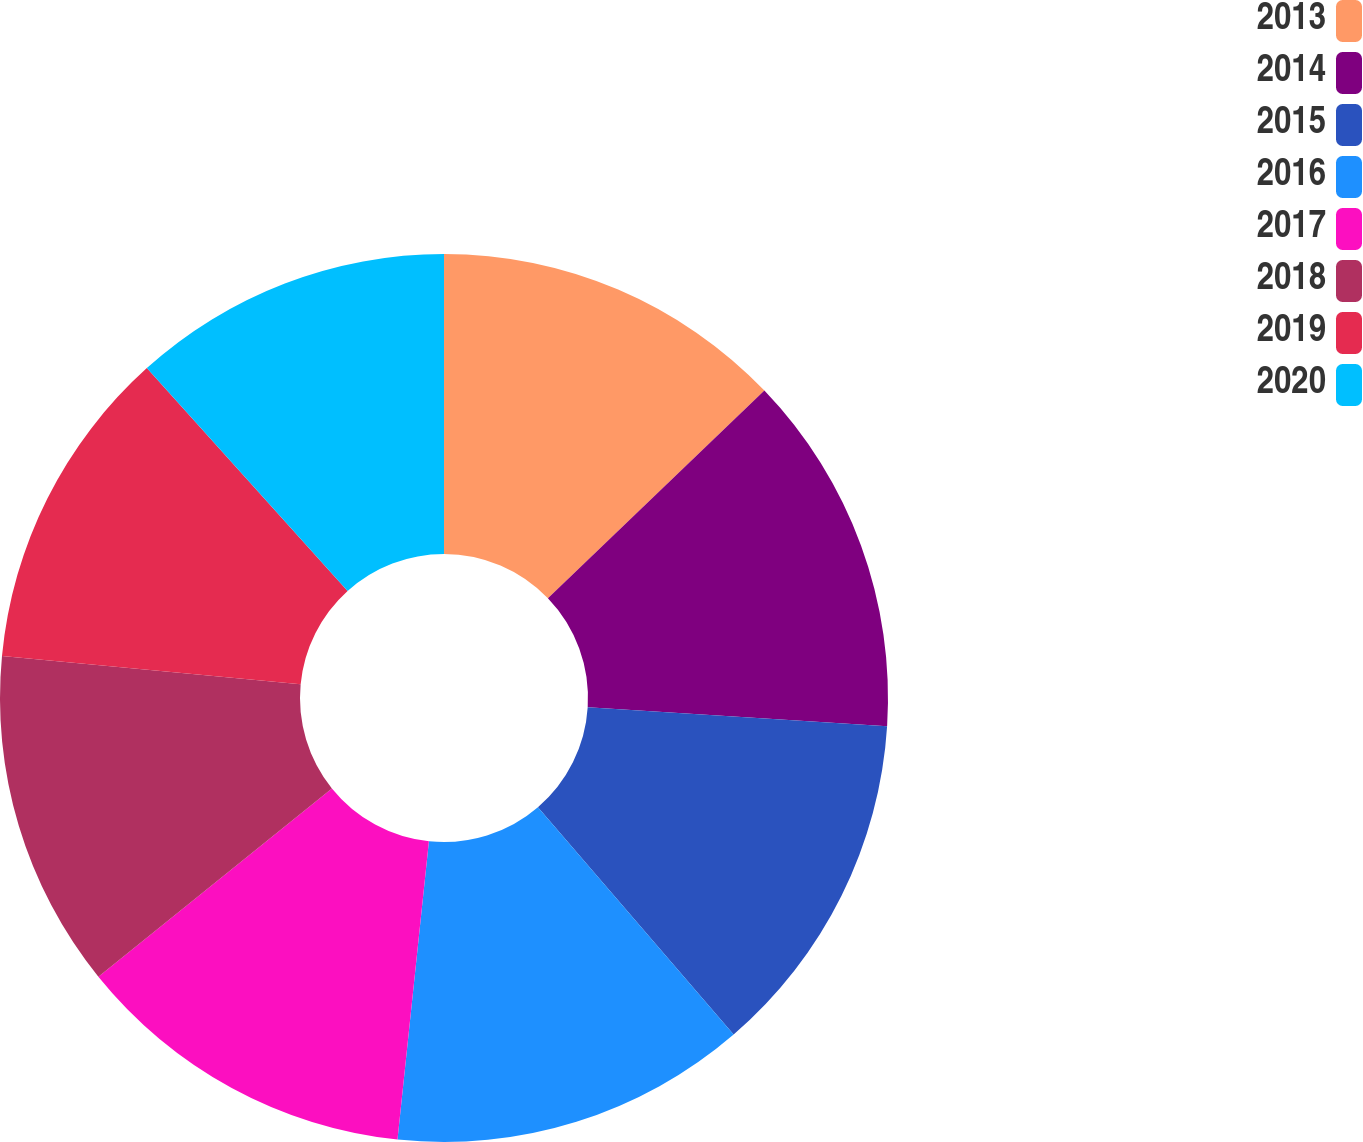Convert chart. <chart><loc_0><loc_0><loc_500><loc_500><pie_chart><fcel>2013<fcel>2014<fcel>2015<fcel>2016<fcel>2017<fcel>2018<fcel>2019<fcel>2020<nl><fcel>12.83%<fcel>13.18%<fcel>12.68%<fcel>12.98%<fcel>12.53%<fcel>12.31%<fcel>11.82%<fcel>11.67%<nl></chart> 